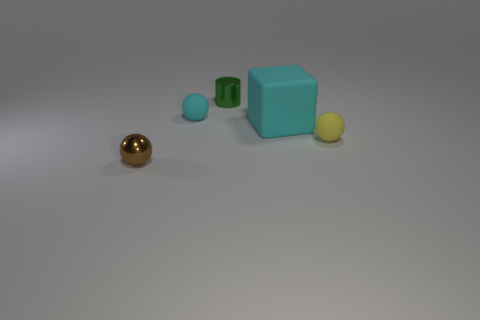There is a sphere that is in front of the yellow matte object; how big is it?
Your response must be concise. Small. Do the metallic sphere and the cylinder have the same size?
Offer a terse response. Yes. Are there fewer big rubber blocks that are on the left side of the cyan rubber ball than cyan rubber balls that are in front of the brown metal sphere?
Give a very brief answer. No. There is a rubber thing that is both left of the small yellow ball and in front of the cyan matte ball; how big is it?
Keep it short and to the point. Large. There is a big matte thing in front of the matte ball that is on the left side of the cyan block; is there a large rubber object that is on the right side of it?
Make the answer very short. No. Are there any small gray matte things?
Give a very brief answer. No. Are there more tiny yellow rubber spheres that are right of the brown metallic sphere than yellow things that are on the right side of the tiny cyan object?
Give a very brief answer. No. There is a cyan object that is the same material as the large cube; what is its size?
Keep it short and to the point. Small. There is a metal object on the right side of the small brown thing in front of the tiny rubber ball that is in front of the cyan ball; how big is it?
Offer a very short reply. Small. What is the color of the rubber sphere in front of the big matte thing?
Ensure brevity in your answer.  Yellow. 